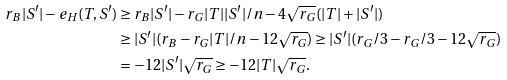<formula> <loc_0><loc_0><loc_500><loc_500>r _ { B } | S ^ { \prime } | - e _ { H } ( T , S ^ { \prime } ) & \geq r _ { B } | S ^ { \prime } | - r _ { G } | T | | S ^ { \prime } | / n - 4 \sqrt { r _ { G } } ( | T | + | S ^ { \prime } | ) \\ & \geq | S ^ { \prime } | ( r _ { B } - r _ { G } | T | / n - 1 2 \sqrt { r _ { G } } ) \geq | S ^ { \prime } | ( r _ { G } / 3 - r _ { G } / 3 - 1 2 \sqrt { r _ { G } } ) \\ & = - 1 2 | S ^ { \prime } | \sqrt { r _ { G } } \geq - 1 2 | T | \sqrt { r _ { G } } .</formula> 